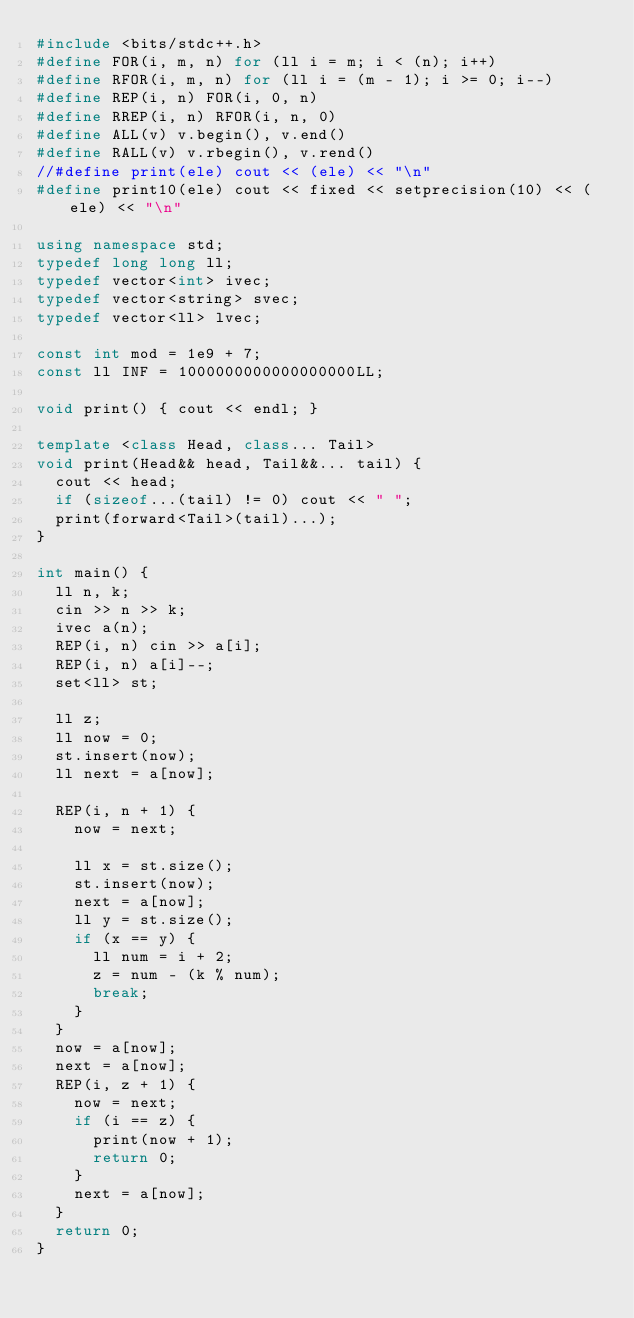<code> <loc_0><loc_0><loc_500><loc_500><_C++_>#include <bits/stdc++.h>
#define FOR(i, m, n) for (ll i = m; i < (n); i++)
#define RFOR(i, m, n) for (ll i = (m - 1); i >= 0; i--)
#define REP(i, n) FOR(i, 0, n)
#define RREP(i, n) RFOR(i, n, 0)
#define ALL(v) v.begin(), v.end()
#define RALL(v) v.rbegin(), v.rend()
//#define print(ele) cout << (ele) << "\n"
#define print10(ele) cout << fixed << setprecision(10) << (ele) << "\n"

using namespace std;
typedef long long ll;
typedef vector<int> ivec;
typedef vector<string> svec;
typedef vector<ll> lvec;

const int mod = 1e9 + 7;
const ll INF = 1000000000000000000LL;

void print() { cout << endl; }

template <class Head, class... Tail>
void print(Head&& head, Tail&&... tail) {
  cout << head;
  if (sizeof...(tail) != 0) cout << " ";
  print(forward<Tail>(tail)...);
}

int main() {
  ll n, k;
  cin >> n >> k;
  ivec a(n);
  REP(i, n) cin >> a[i];
  REP(i, n) a[i]--;
  set<ll> st;

  ll z;
  ll now = 0;
  st.insert(now);
  ll next = a[now];

  REP(i, n + 1) {
    now = next;

    ll x = st.size();
    st.insert(now);
    next = a[now];
    ll y = st.size();
    if (x == y) {
      ll num = i + 2;
      z = num - (k % num);
      break;
    }
  }
  now = a[now];
  next = a[now];
  REP(i, z + 1) {
    now = next;
    if (i == z) {
      print(now + 1);
      return 0;
    }
    next = a[now];
  }
  return 0;
}</code> 